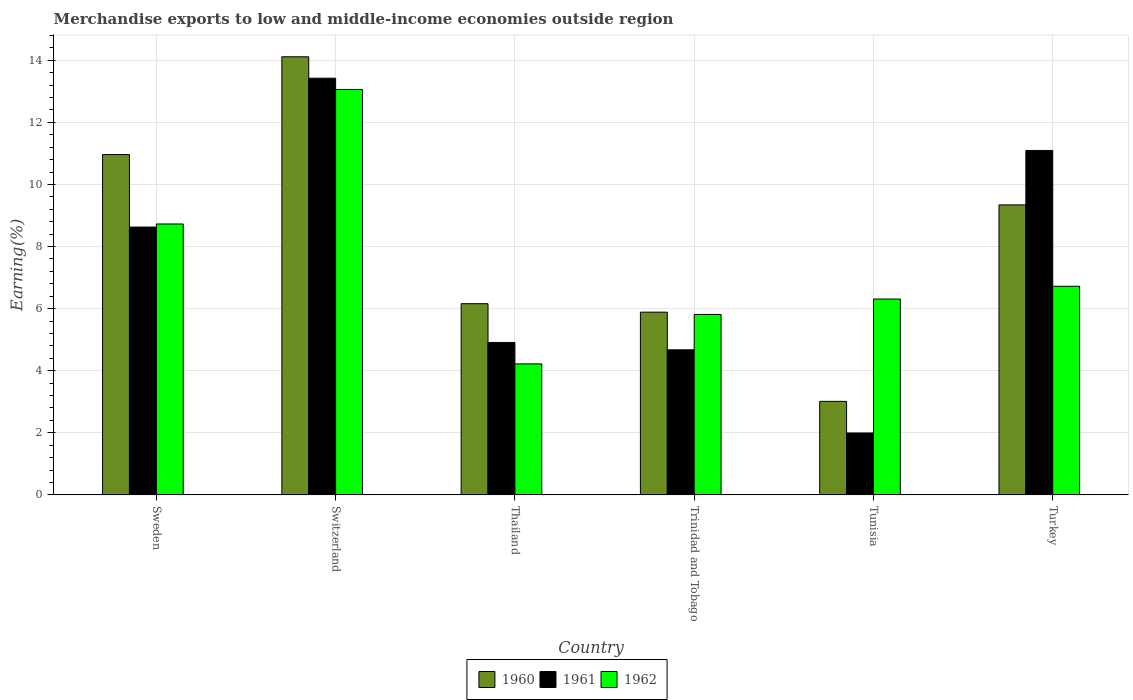How many different coloured bars are there?
Your answer should be compact. 3. How many groups of bars are there?
Your response must be concise. 6. How many bars are there on the 3rd tick from the right?
Provide a short and direct response. 3. What is the label of the 5th group of bars from the left?
Make the answer very short. Tunisia. In how many cases, is the number of bars for a given country not equal to the number of legend labels?
Provide a short and direct response. 0. What is the percentage of amount earned from merchandise exports in 1960 in Tunisia?
Offer a very short reply. 3.01. Across all countries, what is the maximum percentage of amount earned from merchandise exports in 1961?
Make the answer very short. 13.42. Across all countries, what is the minimum percentage of amount earned from merchandise exports in 1961?
Your response must be concise. 1.99. In which country was the percentage of amount earned from merchandise exports in 1961 maximum?
Provide a short and direct response. Switzerland. In which country was the percentage of amount earned from merchandise exports in 1962 minimum?
Provide a short and direct response. Thailand. What is the total percentage of amount earned from merchandise exports in 1962 in the graph?
Your response must be concise. 44.85. What is the difference between the percentage of amount earned from merchandise exports in 1962 in Thailand and that in Trinidad and Tobago?
Your answer should be compact. -1.59. What is the difference between the percentage of amount earned from merchandise exports in 1962 in Switzerland and the percentage of amount earned from merchandise exports in 1961 in Trinidad and Tobago?
Provide a short and direct response. 8.39. What is the average percentage of amount earned from merchandise exports in 1962 per country?
Offer a very short reply. 7.48. What is the difference between the percentage of amount earned from merchandise exports of/in 1961 and percentage of amount earned from merchandise exports of/in 1960 in Tunisia?
Provide a succinct answer. -1.02. What is the ratio of the percentage of amount earned from merchandise exports in 1962 in Trinidad and Tobago to that in Tunisia?
Make the answer very short. 0.92. Is the difference between the percentage of amount earned from merchandise exports in 1961 in Switzerland and Thailand greater than the difference between the percentage of amount earned from merchandise exports in 1960 in Switzerland and Thailand?
Your answer should be very brief. Yes. What is the difference between the highest and the second highest percentage of amount earned from merchandise exports in 1961?
Your answer should be compact. -2.47. What is the difference between the highest and the lowest percentage of amount earned from merchandise exports in 1961?
Offer a terse response. 11.43. In how many countries, is the percentage of amount earned from merchandise exports in 1960 greater than the average percentage of amount earned from merchandise exports in 1960 taken over all countries?
Your response must be concise. 3. Is the sum of the percentage of amount earned from merchandise exports in 1960 in Trinidad and Tobago and Turkey greater than the maximum percentage of amount earned from merchandise exports in 1962 across all countries?
Offer a very short reply. Yes. What does the 1st bar from the left in Tunisia represents?
Your response must be concise. 1960. What does the 3rd bar from the right in Thailand represents?
Ensure brevity in your answer.  1960. Is it the case that in every country, the sum of the percentage of amount earned from merchandise exports in 1962 and percentage of amount earned from merchandise exports in 1961 is greater than the percentage of amount earned from merchandise exports in 1960?
Your answer should be very brief. Yes. How many bars are there?
Your answer should be very brief. 18. Are all the bars in the graph horizontal?
Provide a short and direct response. No. How many countries are there in the graph?
Ensure brevity in your answer.  6. What is the difference between two consecutive major ticks on the Y-axis?
Provide a succinct answer. 2. Are the values on the major ticks of Y-axis written in scientific E-notation?
Make the answer very short. No. Does the graph contain grids?
Provide a succinct answer. Yes. How are the legend labels stacked?
Give a very brief answer. Horizontal. What is the title of the graph?
Your answer should be very brief. Merchandise exports to low and middle-income economies outside region. Does "2001" appear as one of the legend labels in the graph?
Offer a terse response. No. What is the label or title of the X-axis?
Offer a terse response. Country. What is the label or title of the Y-axis?
Offer a terse response. Earning(%). What is the Earning(%) of 1960 in Sweden?
Give a very brief answer. 10.96. What is the Earning(%) of 1961 in Sweden?
Your answer should be compact. 8.63. What is the Earning(%) in 1962 in Sweden?
Make the answer very short. 8.73. What is the Earning(%) of 1960 in Switzerland?
Provide a short and direct response. 14.11. What is the Earning(%) in 1961 in Switzerland?
Offer a terse response. 13.42. What is the Earning(%) in 1962 in Switzerland?
Your answer should be compact. 13.06. What is the Earning(%) of 1960 in Thailand?
Keep it short and to the point. 6.16. What is the Earning(%) in 1961 in Thailand?
Your answer should be very brief. 4.91. What is the Earning(%) in 1962 in Thailand?
Your response must be concise. 4.22. What is the Earning(%) in 1960 in Trinidad and Tobago?
Keep it short and to the point. 5.89. What is the Earning(%) of 1961 in Trinidad and Tobago?
Offer a terse response. 4.67. What is the Earning(%) in 1962 in Trinidad and Tobago?
Ensure brevity in your answer.  5.81. What is the Earning(%) of 1960 in Tunisia?
Offer a terse response. 3.01. What is the Earning(%) in 1961 in Tunisia?
Provide a succinct answer. 1.99. What is the Earning(%) of 1962 in Tunisia?
Make the answer very short. 6.31. What is the Earning(%) of 1960 in Turkey?
Ensure brevity in your answer.  9.34. What is the Earning(%) of 1961 in Turkey?
Ensure brevity in your answer.  11.1. What is the Earning(%) of 1962 in Turkey?
Provide a short and direct response. 6.72. Across all countries, what is the maximum Earning(%) of 1960?
Your answer should be compact. 14.11. Across all countries, what is the maximum Earning(%) in 1961?
Your answer should be very brief. 13.42. Across all countries, what is the maximum Earning(%) of 1962?
Your answer should be very brief. 13.06. Across all countries, what is the minimum Earning(%) in 1960?
Ensure brevity in your answer.  3.01. Across all countries, what is the minimum Earning(%) in 1961?
Give a very brief answer. 1.99. Across all countries, what is the minimum Earning(%) in 1962?
Give a very brief answer. 4.22. What is the total Earning(%) of 1960 in the graph?
Offer a terse response. 49.48. What is the total Earning(%) of 1961 in the graph?
Ensure brevity in your answer.  44.72. What is the total Earning(%) of 1962 in the graph?
Provide a succinct answer. 44.85. What is the difference between the Earning(%) of 1960 in Sweden and that in Switzerland?
Offer a terse response. -3.15. What is the difference between the Earning(%) of 1961 in Sweden and that in Switzerland?
Ensure brevity in your answer.  -4.8. What is the difference between the Earning(%) of 1962 in Sweden and that in Switzerland?
Your answer should be compact. -4.33. What is the difference between the Earning(%) in 1960 in Sweden and that in Thailand?
Give a very brief answer. 4.8. What is the difference between the Earning(%) of 1961 in Sweden and that in Thailand?
Keep it short and to the point. 3.72. What is the difference between the Earning(%) in 1962 in Sweden and that in Thailand?
Your answer should be compact. 4.51. What is the difference between the Earning(%) of 1960 in Sweden and that in Trinidad and Tobago?
Ensure brevity in your answer.  5.08. What is the difference between the Earning(%) in 1961 in Sweden and that in Trinidad and Tobago?
Keep it short and to the point. 3.95. What is the difference between the Earning(%) of 1962 in Sweden and that in Trinidad and Tobago?
Give a very brief answer. 2.91. What is the difference between the Earning(%) in 1960 in Sweden and that in Tunisia?
Offer a terse response. 7.95. What is the difference between the Earning(%) in 1961 in Sweden and that in Tunisia?
Keep it short and to the point. 6.63. What is the difference between the Earning(%) in 1962 in Sweden and that in Tunisia?
Give a very brief answer. 2.42. What is the difference between the Earning(%) of 1960 in Sweden and that in Turkey?
Your answer should be very brief. 1.62. What is the difference between the Earning(%) in 1961 in Sweden and that in Turkey?
Make the answer very short. -2.47. What is the difference between the Earning(%) of 1962 in Sweden and that in Turkey?
Ensure brevity in your answer.  2.01. What is the difference between the Earning(%) in 1960 in Switzerland and that in Thailand?
Make the answer very short. 7.95. What is the difference between the Earning(%) of 1961 in Switzerland and that in Thailand?
Your answer should be compact. 8.51. What is the difference between the Earning(%) of 1962 in Switzerland and that in Thailand?
Make the answer very short. 8.84. What is the difference between the Earning(%) in 1960 in Switzerland and that in Trinidad and Tobago?
Your response must be concise. 8.23. What is the difference between the Earning(%) of 1961 in Switzerland and that in Trinidad and Tobago?
Your answer should be very brief. 8.75. What is the difference between the Earning(%) of 1962 in Switzerland and that in Trinidad and Tobago?
Provide a succinct answer. 7.25. What is the difference between the Earning(%) of 1960 in Switzerland and that in Tunisia?
Your answer should be compact. 11.1. What is the difference between the Earning(%) of 1961 in Switzerland and that in Tunisia?
Your response must be concise. 11.43. What is the difference between the Earning(%) of 1962 in Switzerland and that in Tunisia?
Make the answer very short. 6.75. What is the difference between the Earning(%) in 1960 in Switzerland and that in Turkey?
Keep it short and to the point. 4.77. What is the difference between the Earning(%) in 1961 in Switzerland and that in Turkey?
Make the answer very short. 2.33. What is the difference between the Earning(%) of 1962 in Switzerland and that in Turkey?
Keep it short and to the point. 6.34. What is the difference between the Earning(%) in 1960 in Thailand and that in Trinidad and Tobago?
Keep it short and to the point. 0.27. What is the difference between the Earning(%) of 1961 in Thailand and that in Trinidad and Tobago?
Offer a terse response. 0.24. What is the difference between the Earning(%) in 1962 in Thailand and that in Trinidad and Tobago?
Offer a terse response. -1.59. What is the difference between the Earning(%) in 1960 in Thailand and that in Tunisia?
Offer a very short reply. 3.15. What is the difference between the Earning(%) in 1961 in Thailand and that in Tunisia?
Give a very brief answer. 2.92. What is the difference between the Earning(%) of 1962 in Thailand and that in Tunisia?
Your response must be concise. -2.09. What is the difference between the Earning(%) in 1960 in Thailand and that in Turkey?
Give a very brief answer. -3.18. What is the difference between the Earning(%) of 1961 in Thailand and that in Turkey?
Your answer should be very brief. -6.19. What is the difference between the Earning(%) in 1962 in Thailand and that in Turkey?
Provide a short and direct response. -2.5. What is the difference between the Earning(%) in 1960 in Trinidad and Tobago and that in Tunisia?
Ensure brevity in your answer.  2.87. What is the difference between the Earning(%) of 1961 in Trinidad and Tobago and that in Tunisia?
Keep it short and to the point. 2.68. What is the difference between the Earning(%) of 1962 in Trinidad and Tobago and that in Tunisia?
Your answer should be compact. -0.5. What is the difference between the Earning(%) in 1960 in Trinidad and Tobago and that in Turkey?
Give a very brief answer. -3.46. What is the difference between the Earning(%) in 1961 in Trinidad and Tobago and that in Turkey?
Your answer should be very brief. -6.42. What is the difference between the Earning(%) in 1962 in Trinidad and Tobago and that in Turkey?
Provide a succinct answer. -0.91. What is the difference between the Earning(%) of 1960 in Tunisia and that in Turkey?
Offer a terse response. -6.33. What is the difference between the Earning(%) in 1961 in Tunisia and that in Turkey?
Offer a very short reply. -9.1. What is the difference between the Earning(%) of 1962 in Tunisia and that in Turkey?
Keep it short and to the point. -0.41. What is the difference between the Earning(%) in 1960 in Sweden and the Earning(%) in 1961 in Switzerland?
Provide a succinct answer. -2.46. What is the difference between the Earning(%) of 1960 in Sweden and the Earning(%) of 1962 in Switzerland?
Offer a very short reply. -2.1. What is the difference between the Earning(%) in 1961 in Sweden and the Earning(%) in 1962 in Switzerland?
Give a very brief answer. -4.43. What is the difference between the Earning(%) in 1960 in Sweden and the Earning(%) in 1961 in Thailand?
Provide a short and direct response. 6.05. What is the difference between the Earning(%) in 1960 in Sweden and the Earning(%) in 1962 in Thailand?
Your answer should be compact. 6.74. What is the difference between the Earning(%) of 1961 in Sweden and the Earning(%) of 1962 in Thailand?
Provide a succinct answer. 4.41. What is the difference between the Earning(%) of 1960 in Sweden and the Earning(%) of 1961 in Trinidad and Tobago?
Your answer should be very brief. 6.29. What is the difference between the Earning(%) in 1960 in Sweden and the Earning(%) in 1962 in Trinidad and Tobago?
Offer a terse response. 5.15. What is the difference between the Earning(%) in 1961 in Sweden and the Earning(%) in 1962 in Trinidad and Tobago?
Provide a short and direct response. 2.81. What is the difference between the Earning(%) of 1960 in Sweden and the Earning(%) of 1961 in Tunisia?
Provide a succinct answer. 8.97. What is the difference between the Earning(%) of 1960 in Sweden and the Earning(%) of 1962 in Tunisia?
Make the answer very short. 4.65. What is the difference between the Earning(%) in 1961 in Sweden and the Earning(%) in 1962 in Tunisia?
Ensure brevity in your answer.  2.32. What is the difference between the Earning(%) of 1960 in Sweden and the Earning(%) of 1961 in Turkey?
Offer a very short reply. -0.13. What is the difference between the Earning(%) in 1960 in Sweden and the Earning(%) in 1962 in Turkey?
Give a very brief answer. 4.24. What is the difference between the Earning(%) of 1961 in Sweden and the Earning(%) of 1962 in Turkey?
Your answer should be very brief. 1.91. What is the difference between the Earning(%) in 1960 in Switzerland and the Earning(%) in 1961 in Thailand?
Offer a terse response. 9.2. What is the difference between the Earning(%) in 1960 in Switzerland and the Earning(%) in 1962 in Thailand?
Ensure brevity in your answer.  9.89. What is the difference between the Earning(%) in 1961 in Switzerland and the Earning(%) in 1962 in Thailand?
Offer a terse response. 9.2. What is the difference between the Earning(%) of 1960 in Switzerland and the Earning(%) of 1961 in Trinidad and Tobago?
Make the answer very short. 9.44. What is the difference between the Earning(%) of 1960 in Switzerland and the Earning(%) of 1962 in Trinidad and Tobago?
Your answer should be compact. 8.3. What is the difference between the Earning(%) in 1961 in Switzerland and the Earning(%) in 1962 in Trinidad and Tobago?
Provide a succinct answer. 7.61. What is the difference between the Earning(%) of 1960 in Switzerland and the Earning(%) of 1961 in Tunisia?
Make the answer very short. 12.12. What is the difference between the Earning(%) of 1960 in Switzerland and the Earning(%) of 1962 in Tunisia?
Keep it short and to the point. 7.8. What is the difference between the Earning(%) in 1961 in Switzerland and the Earning(%) in 1962 in Tunisia?
Provide a short and direct response. 7.11. What is the difference between the Earning(%) in 1960 in Switzerland and the Earning(%) in 1961 in Turkey?
Provide a succinct answer. 3.02. What is the difference between the Earning(%) in 1960 in Switzerland and the Earning(%) in 1962 in Turkey?
Your answer should be compact. 7.39. What is the difference between the Earning(%) in 1961 in Switzerland and the Earning(%) in 1962 in Turkey?
Your answer should be very brief. 6.7. What is the difference between the Earning(%) of 1960 in Thailand and the Earning(%) of 1961 in Trinidad and Tobago?
Give a very brief answer. 1.49. What is the difference between the Earning(%) in 1960 in Thailand and the Earning(%) in 1962 in Trinidad and Tobago?
Your response must be concise. 0.35. What is the difference between the Earning(%) of 1961 in Thailand and the Earning(%) of 1962 in Trinidad and Tobago?
Make the answer very short. -0.9. What is the difference between the Earning(%) of 1960 in Thailand and the Earning(%) of 1961 in Tunisia?
Offer a very short reply. 4.16. What is the difference between the Earning(%) in 1960 in Thailand and the Earning(%) in 1962 in Tunisia?
Offer a very short reply. -0.15. What is the difference between the Earning(%) in 1961 in Thailand and the Earning(%) in 1962 in Tunisia?
Ensure brevity in your answer.  -1.4. What is the difference between the Earning(%) in 1960 in Thailand and the Earning(%) in 1961 in Turkey?
Your answer should be very brief. -4.94. What is the difference between the Earning(%) in 1960 in Thailand and the Earning(%) in 1962 in Turkey?
Offer a terse response. -0.56. What is the difference between the Earning(%) in 1961 in Thailand and the Earning(%) in 1962 in Turkey?
Ensure brevity in your answer.  -1.81. What is the difference between the Earning(%) of 1960 in Trinidad and Tobago and the Earning(%) of 1961 in Tunisia?
Give a very brief answer. 3.89. What is the difference between the Earning(%) in 1960 in Trinidad and Tobago and the Earning(%) in 1962 in Tunisia?
Provide a short and direct response. -0.42. What is the difference between the Earning(%) of 1961 in Trinidad and Tobago and the Earning(%) of 1962 in Tunisia?
Provide a short and direct response. -1.64. What is the difference between the Earning(%) of 1960 in Trinidad and Tobago and the Earning(%) of 1961 in Turkey?
Offer a very short reply. -5.21. What is the difference between the Earning(%) in 1960 in Trinidad and Tobago and the Earning(%) in 1962 in Turkey?
Offer a terse response. -0.83. What is the difference between the Earning(%) of 1961 in Trinidad and Tobago and the Earning(%) of 1962 in Turkey?
Provide a short and direct response. -2.05. What is the difference between the Earning(%) of 1960 in Tunisia and the Earning(%) of 1961 in Turkey?
Make the answer very short. -8.08. What is the difference between the Earning(%) of 1960 in Tunisia and the Earning(%) of 1962 in Turkey?
Make the answer very short. -3.71. What is the difference between the Earning(%) in 1961 in Tunisia and the Earning(%) in 1962 in Turkey?
Your answer should be very brief. -4.73. What is the average Earning(%) in 1960 per country?
Make the answer very short. 8.25. What is the average Earning(%) of 1961 per country?
Your answer should be compact. 7.45. What is the average Earning(%) of 1962 per country?
Offer a terse response. 7.48. What is the difference between the Earning(%) of 1960 and Earning(%) of 1961 in Sweden?
Your answer should be compact. 2.34. What is the difference between the Earning(%) in 1960 and Earning(%) in 1962 in Sweden?
Ensure brevity in your answer.  2.24. What is the difference between the Earning(%) of 1961 and Earning(%) of 1962 in Sweden?
Ensure brevity in your answer.  -0.1. What is the difference between the Earning(%) of 1960 and Earning(%) of 1961 in Switzerland?
Keep it short and to the point. 0.69. What is the difference between the Earning(%) of 1960 and Earning(%) of 1962 in Switzerland?
Your response must be concise. 1.05. What is the difference between the Earning(%) in 1961 and Earning(%) in 1962 in Switzerland?
Offer a very short reply. 0.36. What is the difference between the Earning(%) in 1960 and Earning(%) in 1961 in Thailand?
Give a very brief answer. 1.25. What is the difference between the Earning(%) of 1960 and Earning(%) of 1962 in Thailand?
Provide a succinct answer. 1.94. What is the difference between the Earning(%) of 1961 and Earning(%) of 1962 in Thailand?
Ensure brevity in your answer.  0.69. What is the difference between the Earning(%) in 1960 and Earning(%) in 1961 in Trinidad and Tobago?
Your answer should be very brief. 1.21. What is the difference between the Earning(%) in 1960 and Earning(%) in 1962 in Trinidad and Tobago?
Offer a very short reply. 0.07. What is the difference between the Earning(%) of 1961 and Earning(%) of 1962 in Trinidad and Tobago?
Your response must be concise. -1.14. What is the difference between the Earning(%) of 1960 and Earning(%) of 1961 in Tunisia?
Your answer should be very brief. 1.02. What is the difference between the Earning(%) of 1960 and Earning(%) of 1962 in Tunisia?
Offer a terse response. -3.3. What is the difference between the Earning(%) of 1961 and Earning(%) of 1962 in Tunisia?
Provide a short and direct response. -4.31. What is the difference between the Earning(%) of 1960 and Earning(%) of 1961 in Turkey?
Keep it short and to the point. -1.75. What is the difference between the Earning(%) in 1960 and Earning(%) in 1962 in Turkey?
Provide a short and direct response. 2.62. What is the difference between the Earning(%) in 1961 and Earning(%) in 1962 in Turkey?
Your answer should be compact. 4.37. What is the ratio of the Earning(%) in 1960 in Sweden to that in Switzerland?
Your answer should be very brief. 0.78. What is the ratio of the Earning(%) of 1961 in Sweden to that in Switzerland?
Keep it short and to the point. 0.64. What is the ratio of the Earning(%) in 1962 in Sweden to that in Switzerland?
Your answer should be very brief. 0.67. What is the ratio of the Earning(%) in 1960 in Sweden to that in Thailand?
Give a very brief answer. 1.78. What is the ratio of the Earning(%) in 1961 in Sweden to that in Thailand?
Provide a succinct answer. 1.76. What is the ratio of the Earning(%) in 1962 in Sweden to that in Thailand?
Provide a short and direct response. 2.07. What is the ratio of the Earning(%) of 1960 in Sweden to that in Trinidad and Tobago?
Offer a very short reply. 1.86. What is the ratio of the Earning(%) of 1961 in Sweden to that in Trinidad and Tobago?
Offer a terse response. 1.85. What is the ratio of the Earning(%) of 1962 in Sweden to that in Trinidad and Tobago?
Ensure brevity in your answer.  1.5. What is the ratio of the Earning(%) in 1960 in Sweden to that in Tunisia?
Offer a very short reply. 3.64. What is the ratio of the Earning(%) in 1961 in Sweden to that in Tunisia?
Ensure brevity in your answer.  4.33. What is the ratio of the Earning(%) in 1962 in Sweden to that in Tunisia?
Offer a terse response. 1.38. What is the ratio of the Earning(%) of 1960 in Sweden to that in Turkey?
Your answer should be very brief. 1.17. What is the ratio of the Earning(%) in 1961 in Sweden to that in Turkey?
Your response must be concise. 0.78. What is the ratio of the Earning(%) in 1962 in Sweden to that in Turkey?
Give a very brief answer. 1.3. What is the ratio of the Earning(%) in 1960 in Switzerland to that in Thailand?
Provide a succinct answer. 2.29. What is the ratio of the Earning(%) of 1961 in Switzerland to that in Thailand?
Your answer should be very brief. 2.73. What is the ratio of the Earning(%) in 1962 in Switzerland to that in Thailand?
Ensure brevity in your answer.  3.1. What is the ratio of the Earning(%) in 1960 in Switzerland to that in Trinidad and Tobago?
Offer a very short reply. 2.4. What is the ratio of the Earning(%) in 1961 in Switzerland to that in Trinidad and Tobago?
Give a very brief answer. 2.87. What is the ratio of the Earning(%) in 1962 in Switzerland to that in Trinidad and Tobago?
Provide a short and direct response. 2.25. What is the ratio of the Earning(%) of 1960 in Switzerland to that in Tunisia?
Make the answer very short. 4.68. What is the ratio of the Earning(%) in 1961 in Switzerland to that in Tunisia?
Your response must be concise. 6.73. What is the ratio of the Earning(%) in 1962 in Switzerland to that in Tunisia?
Offer a very short reply. 2.07. What is the ratio of the Earning(%) of 1960 in Switzerland to that in Turkey?
Keep it short and to the point. 1.51. What is the ratio of the Earning(%) in 1961 in Switzerland to that in Turkey?
Your answer should be very brief. 1.21. What is the ratio of the Earning(%) of 1962 in Switzerland to that in Turkey?
Your response must be concise. 1.94. What is the ratio of the Earning(%) of 1960 in Thailand to that in Trinidad and Tobago?
Offer a terse response. 1.05. What is the ratio of the Earning(%) of 1961 in Thailand to that in Trinidad and Tobago?
Keep it short and to the point. 1.05. What is the ratio of the Earning(%) in 1962 in Thailand to that in Trinidad and Tobago?
Ensure brevity in your answer.  0.73. What is the ratio of the Earning(%) of 1960 in Thailand to that in Tunisia?
Offer a very short reply. 2.04. What is the ratio of the Earning(%) in 1961 in Thailand to that in Tunisia?
Your response must be concise. 2.46. What is the ratio of the Earning(%) in 1962 in Thailand to that in Tunisia?
Make the answer very short. 0.67. What is the ratio of the Earning(%) in 1960 in Thailand to that in Turkey?
Give a very brief answer. 0.66. What is the ratio of the Earning(%) of 1961 in Thailand to that in Turkey?
Your response must be concise. 0.44. What is the ratio of the Earning(%) of 1962 in Thailand to that in Turkey?
Offer a very short reply. 0.63. What is the ratio of the Earning(%) of 1960 in Trinidad and Tobago to that in Tunisia?
Offer a very short reply. 1.95. What is the ratio of the Earning(%) in 1961 in Trinidad and Tobago to that in Tunisia?
Offer a very short reply. 2.34. What is the ratio of the Earning(%) of 1962 in Trinidad and Tobago to that in Tunisia?
Your response must be concise. 0.92. What is the ratio of the Earning(%) of 1960 in Trinidad and Tobago to that in Turkey?
Offer a very short reply. 0.63. What is the ratio of the Earning(%) of 1961 in Trinidad and Tobago to that in Turkey?
Keep it short and to the point. 0.42. What is the ratio of the Earning(%) in 1962 in Trinidad and Tobago to that in Turkey?
Your answer should be very brief. 0.86. What is the ratio of the Earning(%) in 1960 in Tunisia to that in Turkey?
Your answer should be very brief. 0.32. What is the ratio of the Earning(%) of 1961 in Tunisia to that in Turkey?
Provide a short and direct response. 0.18. What is the ratio of the Earning(%) of 1962 in Tunisia to that in Turkey?
Give a very brief answer. 0.94. What is the difference between the highest and the second highest Earning(%) of 1960?
Your answer should be very brief. 3.15. What is the difference between the highest and the second highest Earning(%) in 1961?
Keep it short and to the point. 2.33. What is the difference between the highest and the second highest Earning(%) in 1962?
Your answer should be very brief. 4.33. What is the difference between the highest and the lowest Earning(%) in 1960?
Make the answer very short. 11.1. What is the difference between the highest and the lowest Earning(%) of 1961?
Ensure brevity in your answer.  11.43. What is the difference between the highest and the lowest Earning(%) of 1962?
Give a very brief answer. 8.84. 